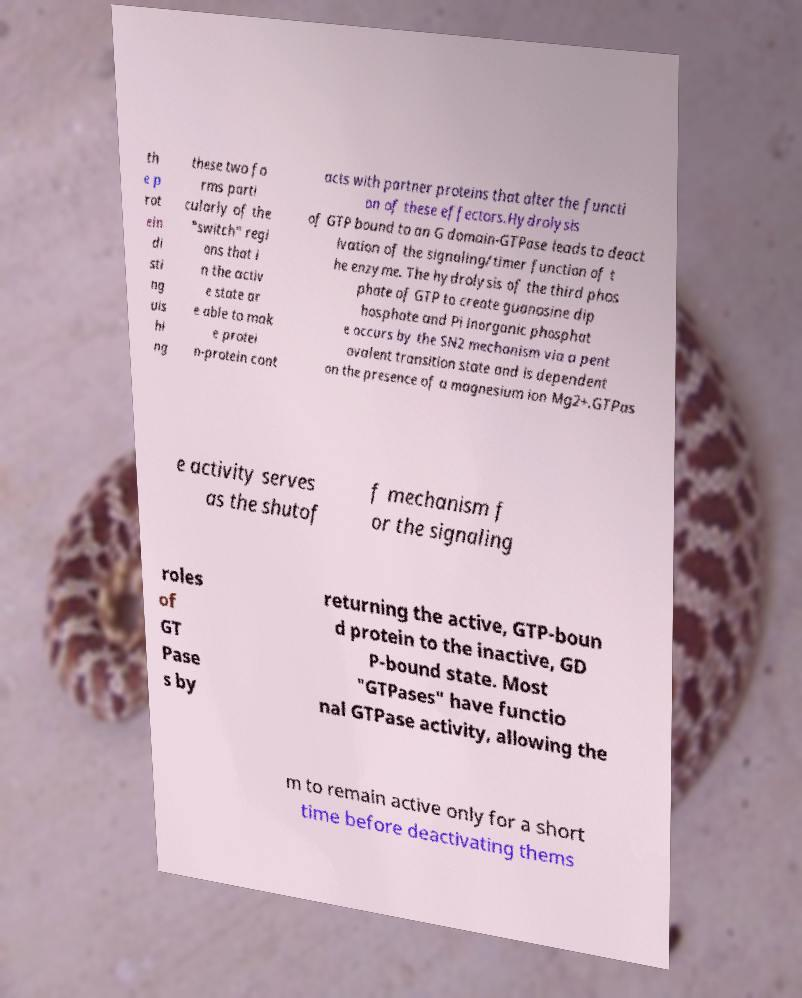I need the written content from this picture converted into text. Can you do that? th e p rot ein di sti ng uis hi ng these two fo rms parti cularly of the "switch" regi ons that i n the activ e state ar e able to mak e protei n-protein cont acts with partner proteins that alter the functi on of these effectors.Hydrolysis of GTP bound to an G domain-GTPase leads to deact ivation of the signaling/timer function of t he enzyme. The hydrolysis of the third phos phate of GTP to create guanosine dip hosphate and Pi inorganic phosphat e occurs by the SN2 mechanism via a pent avalent transition state and is dependent on the presence of a magnesium ion Mg2+.GTPas e activity serves as the shutof f mechanism f or the signaling roles of GT Pase s by returning the active, GTP-boun d protein to the inactive, GD P-bound state. Most "GTPases" have functio nal GTPase activity, allowing the m to remain active only for a short time before deactivating thems 